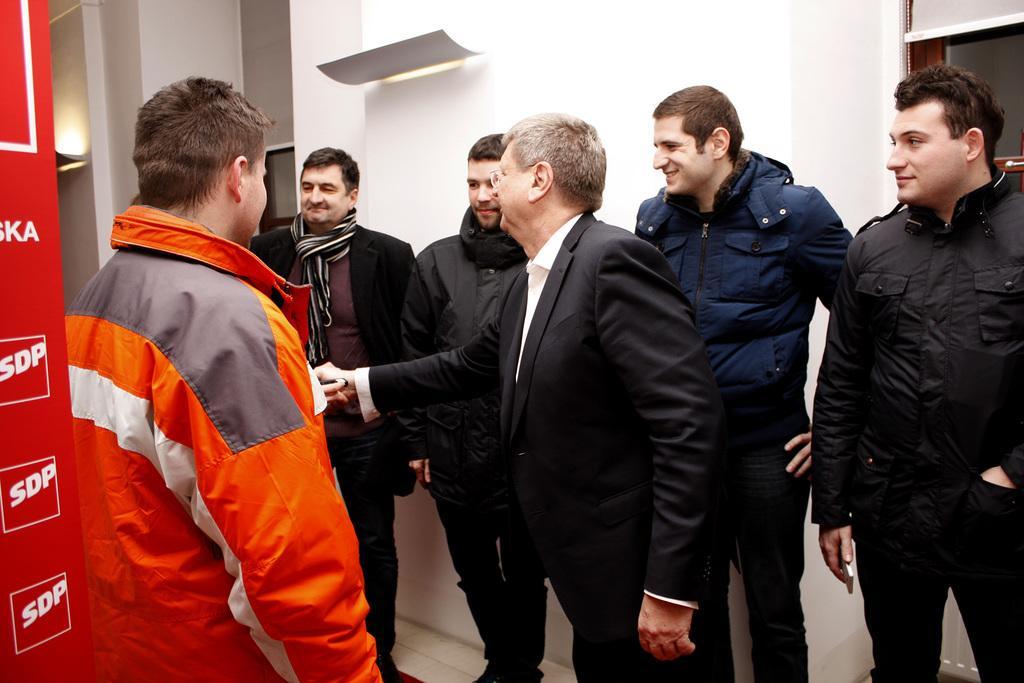Can you describe this image briefly? In this image there are many persons standing in a room. In the background there is wall. All of them are wearing winter clothes. 